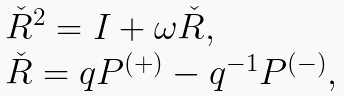Convert formula to latex. <formula><loc_0><loc_0><loc_500><loc_500>\begin{array} { l } { \check { R } } ^ { 2 } = I + \omega { \check { R } } , \\ { \check { R } } = q P ^ { ( + ) } - q ^ { - 1 } P ^ { ( - ) } , \end{array}</formula> 